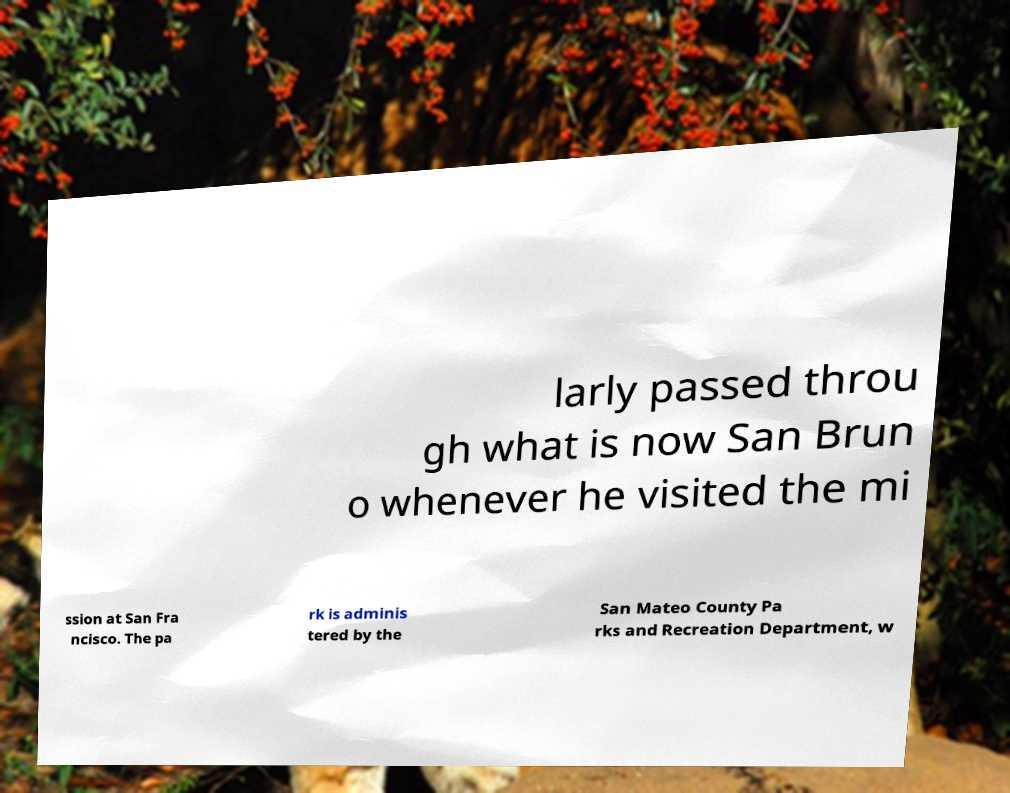I need the written content from this picture converted into text. Can you do that? larly passed throu gh what is now San Brun o whenever he visited the mi ssion at San Fra ncisco. The pa rk is adminis tered by the San Mateo County Pa rks and Recreation Department, w 